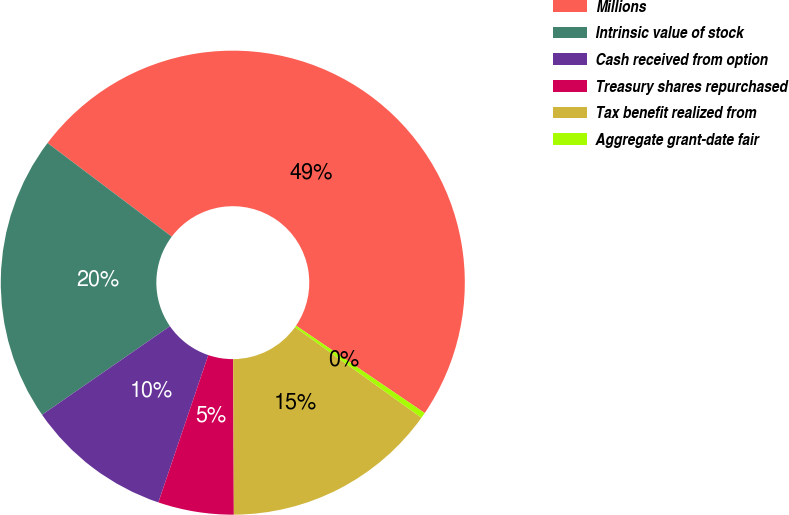Convert chart. <chart><loc_0><loc_0><loc_500><loc_500><pie_chart><fcel>Millions<fcel>Intrinsic value of stock<fcel>Cash received from option<fcel>Treasury shares repurchased<fcel>Tax benefit realized from<fcel>Aggregate grant-date fair<nl><fcel>49.22%<fcel>19.92%<fcel>10.16%<fcel>5.27%<fcel>15.04%<fcel>0.39%<nl></chart> 